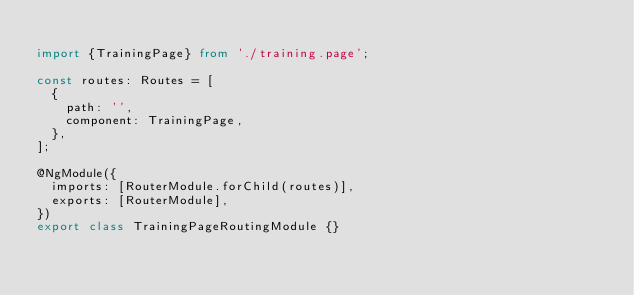Convert code to text. <code><loc_0><loc_0><loc_500><loc_500><_TypeScript_>
import {TrainingPage} from './training.page';

const routes: Routes = [
  {
    path: '',
    component: TrainingPage,
  },
];

@NgModule({
  imports: [RouterModule.forChild(routes)],
  exports: [RouterModule],
})
export class TrainingPageRoutingModule {}
</code> 